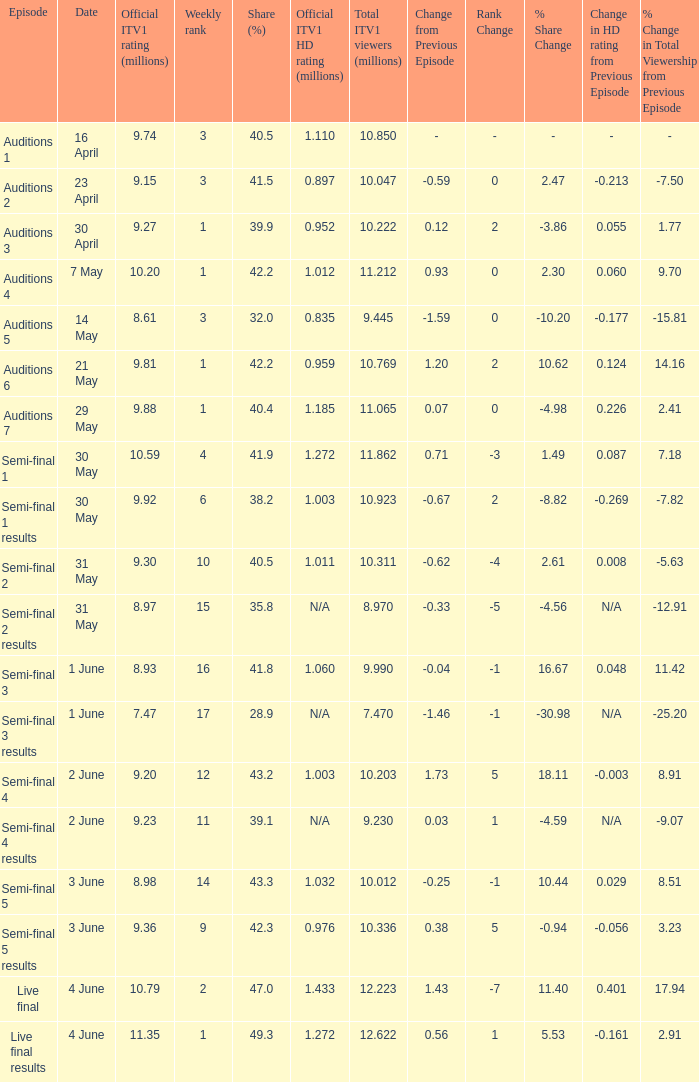What was the official ITV1 rating in millions of the Live Final Results episode? 11.35. 